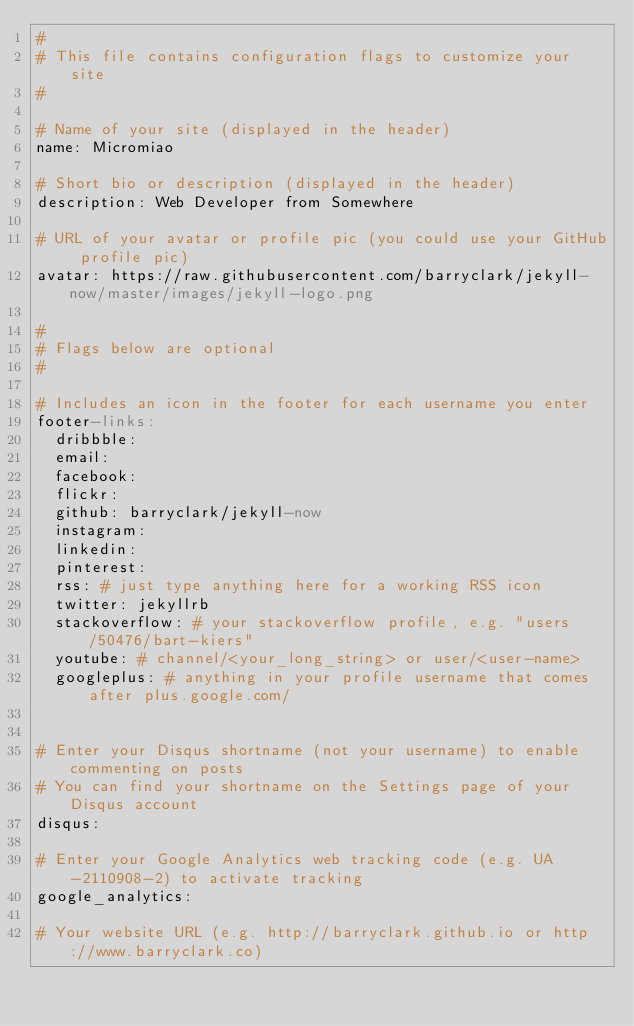<code> <loc_0><loc_0><loc_500><loc_500><_YAML_>#
# This file contains configuration flags to customize your site
#

# Name of your site (displayed in the header)
name: Micromiao

# Short bio or description (displayed in the header)
description: Web Developer from Somewhere

# URL of your avatar or profile pic (you could use your GitHub profile pic)
avatar: https://raw.githubusercontent.com/barryclark/jekyll-now/master/images/jekyll-logo.png

#
# Flags below are optional
#

# Includes an icon in the footer for each username you enter
footer-links:
  dribbble:
  email:
  facebook:
  flickr:
  github: barryclark/jekyll-now
  instagram:
  linkedin:
  pinterest:
  rss: # just type anything here for a working RSS icon
  twitter: jekyllrb
  stackoverflow: # your stackoverflow profile, e.g. "users/50476/bart-kiers"
  youtube: # channel/<your_long_string> or user/<user-name>
  googleplus: # anything in your profile username that comes after plus.google.com/


# Enter your Disqus shortname (not your username) to enable commenting on posts
# You can find your shortname on the Settings page of your Disqus account
disqus:

# Enter your Google Analytics web tracking code (e.g. UA-2110908-2) to activate tracking
google_analytics:

# Your website URL (e.g. http://barryclark.github.io or http://www.barryclark.co)</code> 